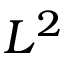<formula> <loc_0><loc_0><loc_500><loc_500>L ^ { 2 }</formula> 